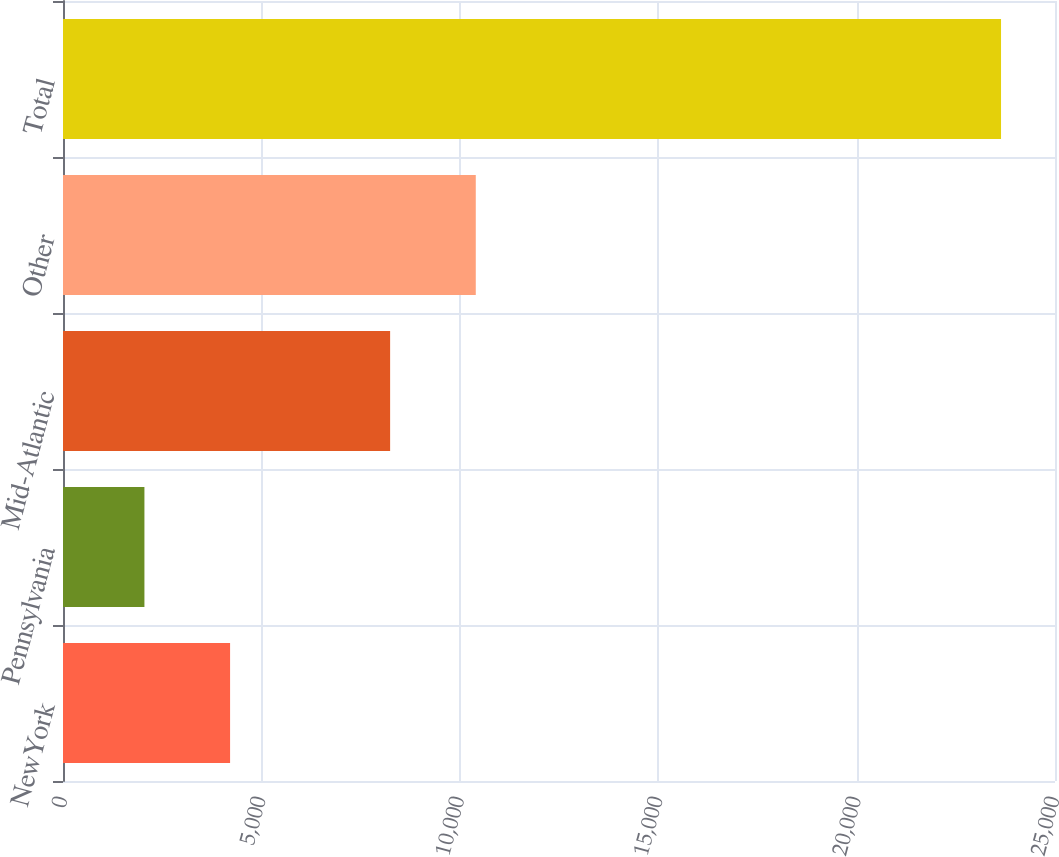<chart> <loc_0><loc_0><loc_500><loc_500><bar_chart><fcel>NewYork<fcel>Pennsylvania<fcel>Mid-Atlantic<fcel>Other<fcel>Total<nl><fcel>4210.8<fcel>2052<fcel>8244<fcel>10402.8<fcel>23640<nl></chart> 